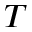Convert formula to latex. <formula><loc_0><loc_0><loc_500><loc_500>T</formula> 